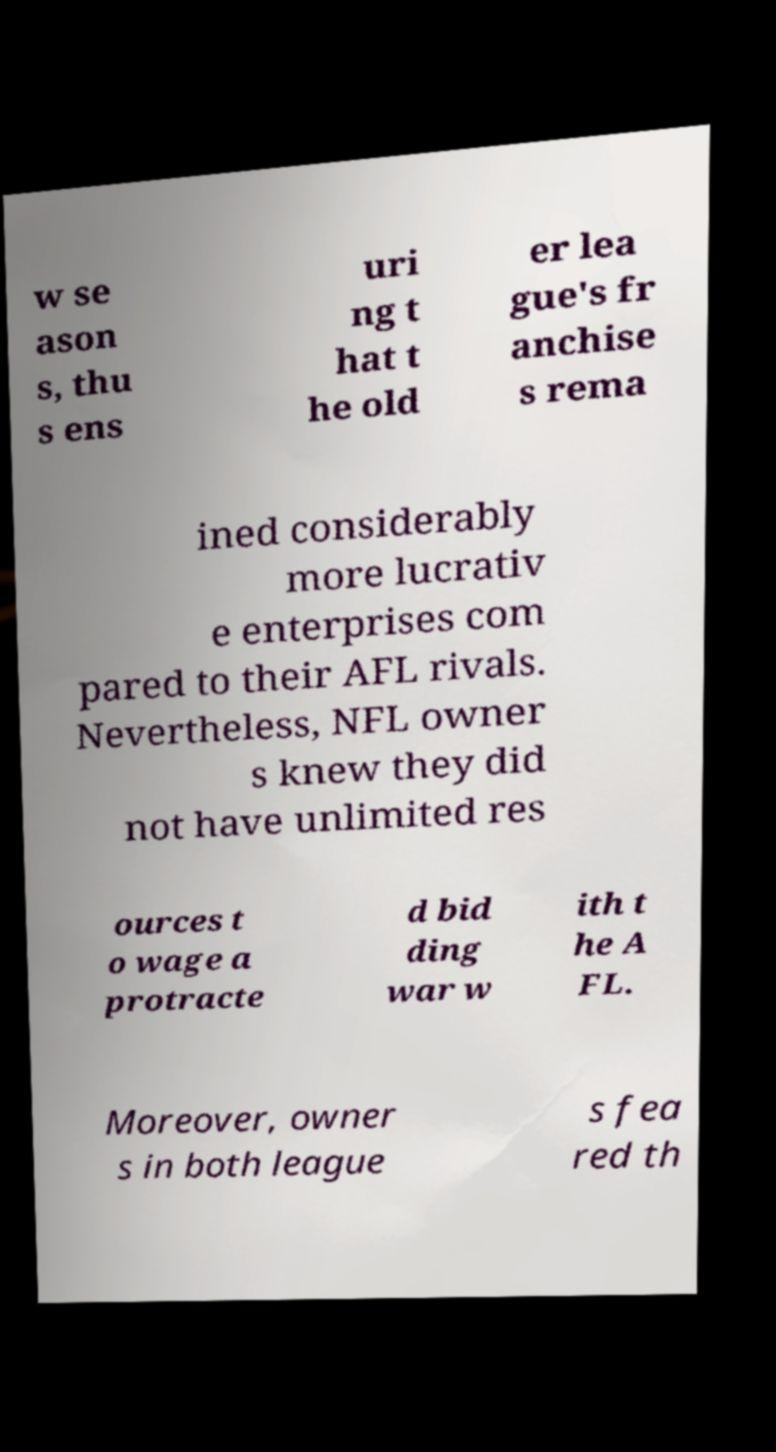What messages or text are displayed in this image? I need them in a readable, typed format. w se ason s, thu s ens uri ng t hat t he old er lea gue's fr anchise s rema ined considerably more lucrativ e enterprises com pared to their AFL rivals. Nevertheless, NFL owner s knew they did not have unlimited res ources t o wage a protracte d bid ding war w ith t he A FL. Moreover, owner s in both league s fea red th 